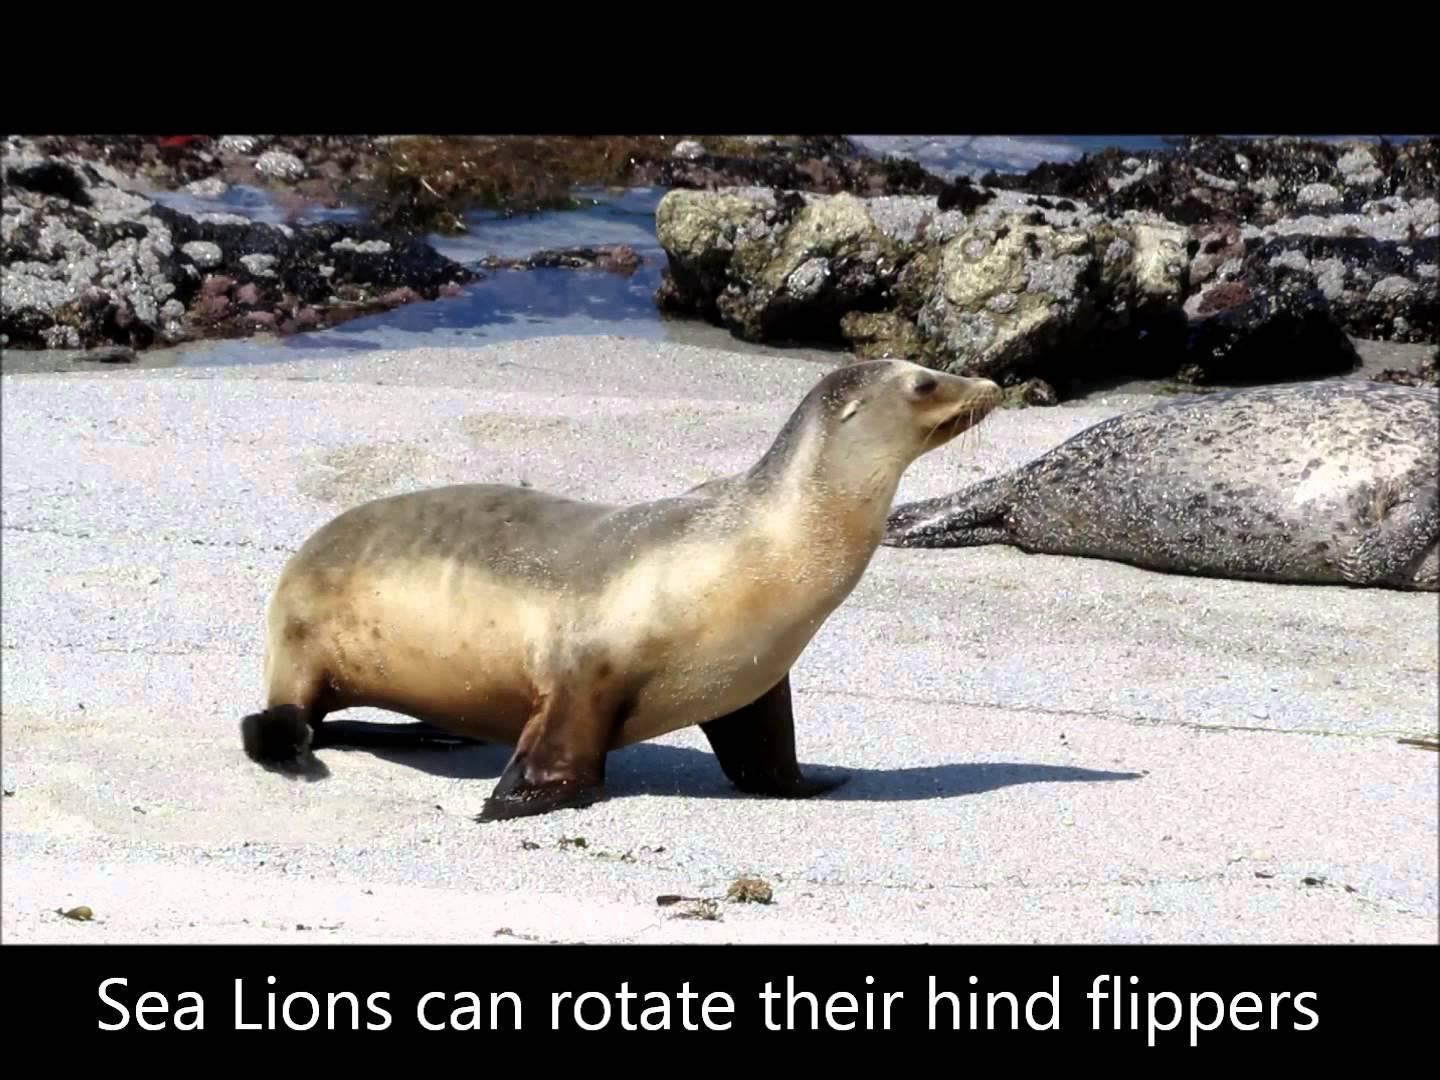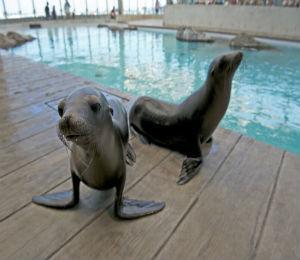The first image is the image on the left, the second image is the image on the right. For the images shown, is this caption "None of the pictures have more than two seals in them." true? Answer yes or no. Yes. 